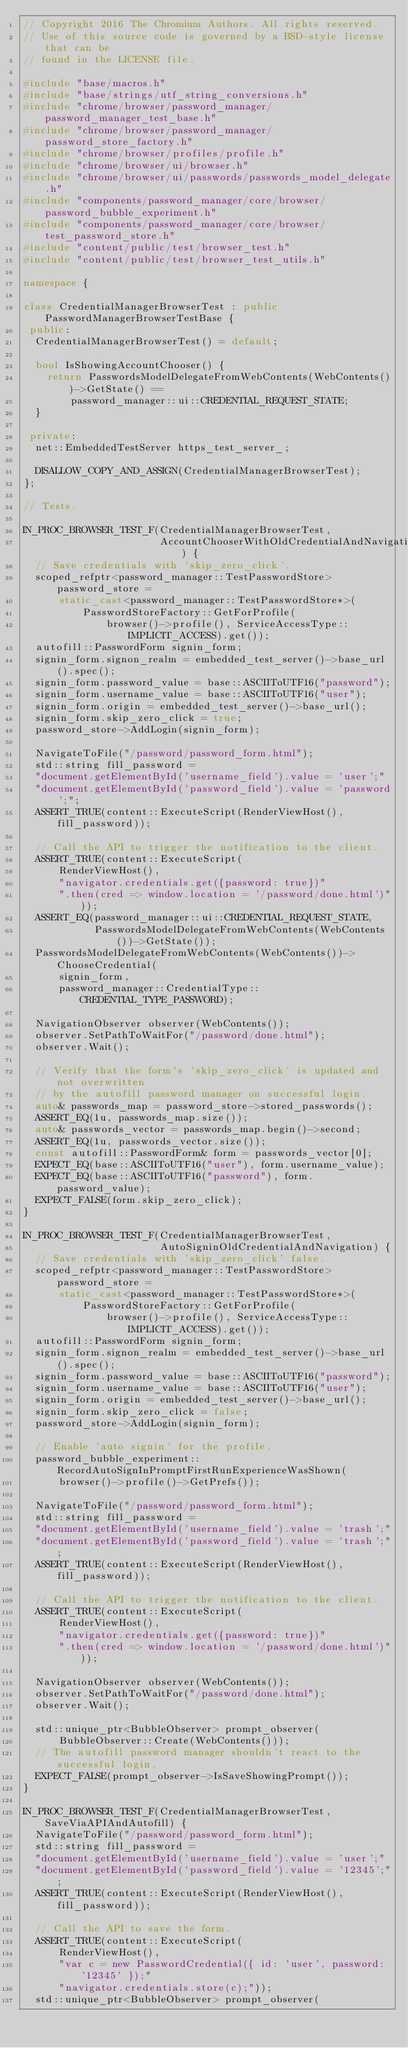Convert code to text. <code><loc_0><loc_0><loc_500><loc_500><_C++_>// Copyright 2016 The Chromium Authors. All rights reserved.
// Use of this source code is governed by a BSD-style license that can be
// found in the LICENSE file.

#include "base/macros.h"
#include "base/strings/utf_string_conversions.h"
#include "chrome/browser/password_manager/password_manager_test_base.h"
#include "chrome/browser/password_manager/password_store_factory.h"
#include "chrome/browser/profiles/profile.h"
#include "chrome/browser/ui/browser.h"
#include "chrome/browser/ui/passwords/passwords_model_delegate.h"
#include "components/password_manager/core/browser/password_bubble_experiment.h"
#include "components/password_manager/core/browser/test_password_store.h"
#include "content/public/test/browser_test.h"
#include "content/public/test/browser_test_utils.h"

namespace {

class CredentialManagerBrowserTest : public PasswordManagerBrowserTestBase {
 public:
  CredentialManagerBrowserTest() = default;

  bool IsShowingAccountChooser() {
    return PasswordsModelDelegateFromWebContents(WebContents())->GetState() ==
        password_manager::ui::CREDENTIAL_REQUEST_STATE;
  }

 private:
  net::EmbeddedTestServer https_test_server_;

  DISALLOW_COPY_AND_ASSIGN(CredentialManagerBrowserTest);
};

// Tests.

IN_PROC_BROWSER_TEST_F(CredentialManagerBrowserTest,
                       AccountChooserWithOldCredentialAndNavigation) {
  // Save credentials with 'skip_zero_click'.
  scoped_refptr<password_manager::TestPasswordStore> password_store =
      static_cast<password_manager::TestPasswordStore*>(
          PasswordStoreFactory::GetForProfile(
              browser()->profile(), ServiceAccessType::IMPLICIT_ACCESS).get());
  autofill::PasswordForm signin_form;
  signin_form.signon_realm = embedded_test_server()->base_url().spec();
  signin_form.password_value = base::ASCIIToUTF16("password");
  signin_form.username_value = base::ASCIIToUTF16("user");
  signin_form.origin = embedded_test_server()->base_url();
  signin_form.skip_zero_click = true;
  password_store->AddLogin(signin_form);

  NavigateToFile("/password/password_form.html");
  std::string fill_password =
  "document.getElementById('username_field').value = 'user';"
  "document.getElementById('password_field').value = 'password';";
  ASSERT_TRUE(content::ExecuteScript(RenderViewHost(), fill_password));

  // Call the API to trigger the notification to the client.
  ASSERT_TRUE(content::ExecuteScript(
      RenderViewHost(),
      "navigator.credentials.get({password: true})"
      ".then(cred => window.location = '/password/done.html')"));
  ASSERT_EQ(password_manager::ui::CREDENTIAL_REQUEST_STATE,
            PasswordsModelDelegateFromWebContents(WebContents())->GetState());
  PasswordsModelDelegateFromWebContents(WebContents())->ChooseCredential(
      signin_form,
      password_manager::CredentialType::CREDENTIAL_TYPE_PASSWORD);

  NavigationObserver observer(WebContents());
  observer.SetPathToWaitFor("/password/done.html");
  observer.Wait();

  // Verify that the form's 'skip_zero_click' is updated and not overwritten
  // by the autofill password manager on successful login.
  auto& passwords_map = password_store->stored_passwords();
  ASSERT_EQ(1u, passwords_map.size());
  auto& passwords_vector = passwords_map.begin()->second;
  ASSERT_EQ(1u, passwords_vector.size());
  const autofill::PasswordForm& form = passwords_vector[0];
  EXPECT_EQ(base::ASCIIToUTF16("user"), form.username_value);
  EXPECT_EQ(base::ASCIIToUTF16("password"), form.password_value);
  EXPECT_FALSE(form.skip_zero_click);
}

IN_PROC_BROWSER_TEST_F(CredentialManagerBrowserTest,
                       AutoSigninOldCredentialAndNavigation) {
  // Save credentials with 'skip_zero_click' false.
  scoped_refptr<password_manager::TestPasswordStore> password_store =
      static_cast<password_manager::TestPasswordStore*>(
          PasswordStoreFactory::GetForProfile(
              browser()->profile(), ServiceAccessType::IMPLICIT_ACCESS).get());
  autofill::PasswordForm signin_form;
  signin_form.signon_realm = embedded_test_server()->base_url().spec();
  signin_form.password_value = base::ASCIIToUTF16("password");
  signin_form.username_value = base::ASCIIToUTF16("user");
  signin_form.origin = embedded_test_server()->base_url();
  signin_form.skip_zero_click = false;
  password_store->AddLogin(signin_form);

  // Enable 'auto signin' for the profile.
  password_bubble_experiment::RecordAutoSignInPromptFirstRunExperienceWasShown(
      browser()->profile()->GetPrefs());

  NavigateToFile("/password/password_form.html");
  std::string fill_password =
  "document.getElementById('username_field').value = 'trash';"
  "document.getElementById('password_field').value = 'trash';";
  ASSERT_TRUE(content::ExecuteScript(RenderViewHost(), fill_password));

  // Call the API to trigger the notification to the client.
  ASSERT_TRUE(content::ExecuteScript(
      RenderViewHost(),
      "navigator.credentials.get({password: true})"
      ".then(cred => window.location = '/password/done.html')"));

  NavigationObserver observer(WebContents());
  observer.SetPathToWaitFor("/password/done.html");
  observer.Wait();

  std::unique_ptr<BubbleObserver> prompt_observer(
      BubbleObserver::Create(WebContents()));
  // The autofill password manager shouldn't react to the successful login.
  EXPECT_FALSE(prompt_observer->IsSaveShowingPrompt());
}

IN_PROC_BROWSER_TEST_F(CredentialManagerBrowserTest, SaveViaAPIAndAutofill) {
  NavigateToFile("/password/password_form.html");
  std::string fill_password =
  "document.getElementById('username_field').value = 'user';"
  "document.getElementById('password_field').value = '12345';";
  ASSERT_TRUE(content::ExecuteScript(RenderViewHost(), fill_password));

  // Call the API to save the form.
  ASSERT_TRUE(content::ExecuteScript(
      RenderViewHost(),
      "var c = new PasswordCredential({ id: 'user', password: '12345' });"
      "navigator.credentials.store(c);"));
  std::unique_ptr<BubbleObserver> prompt_observer(</code> 